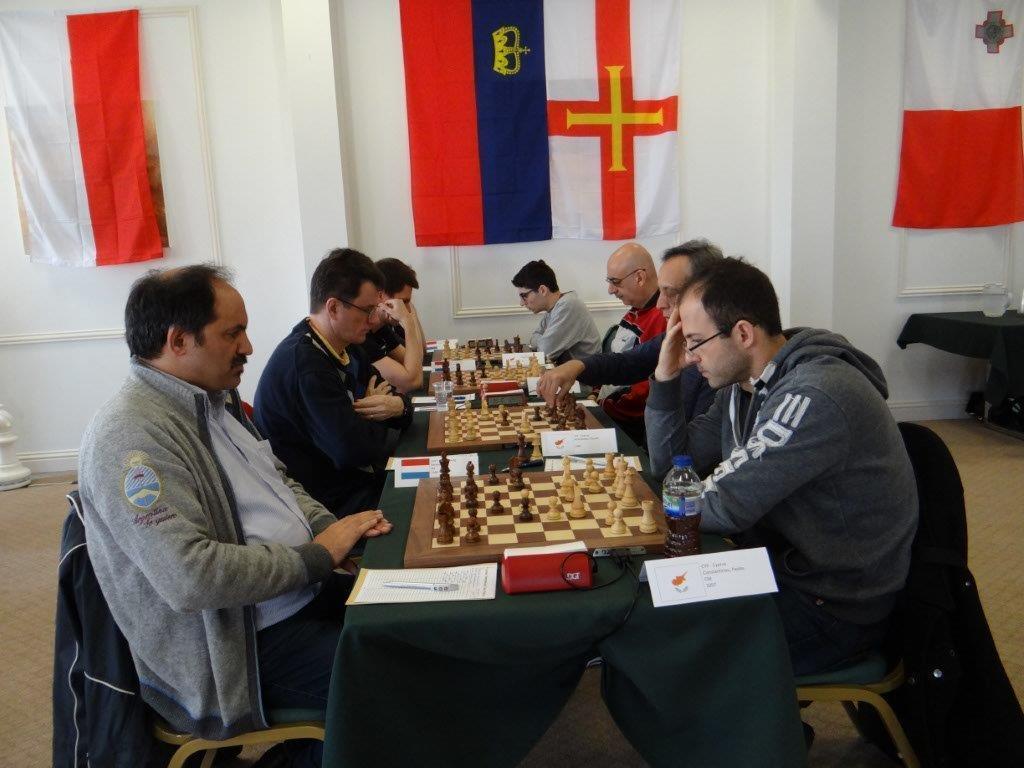Can you describe this image briefly? There are group of persons playing chess in front of their opponents. In background there are some flags on the white wall. 